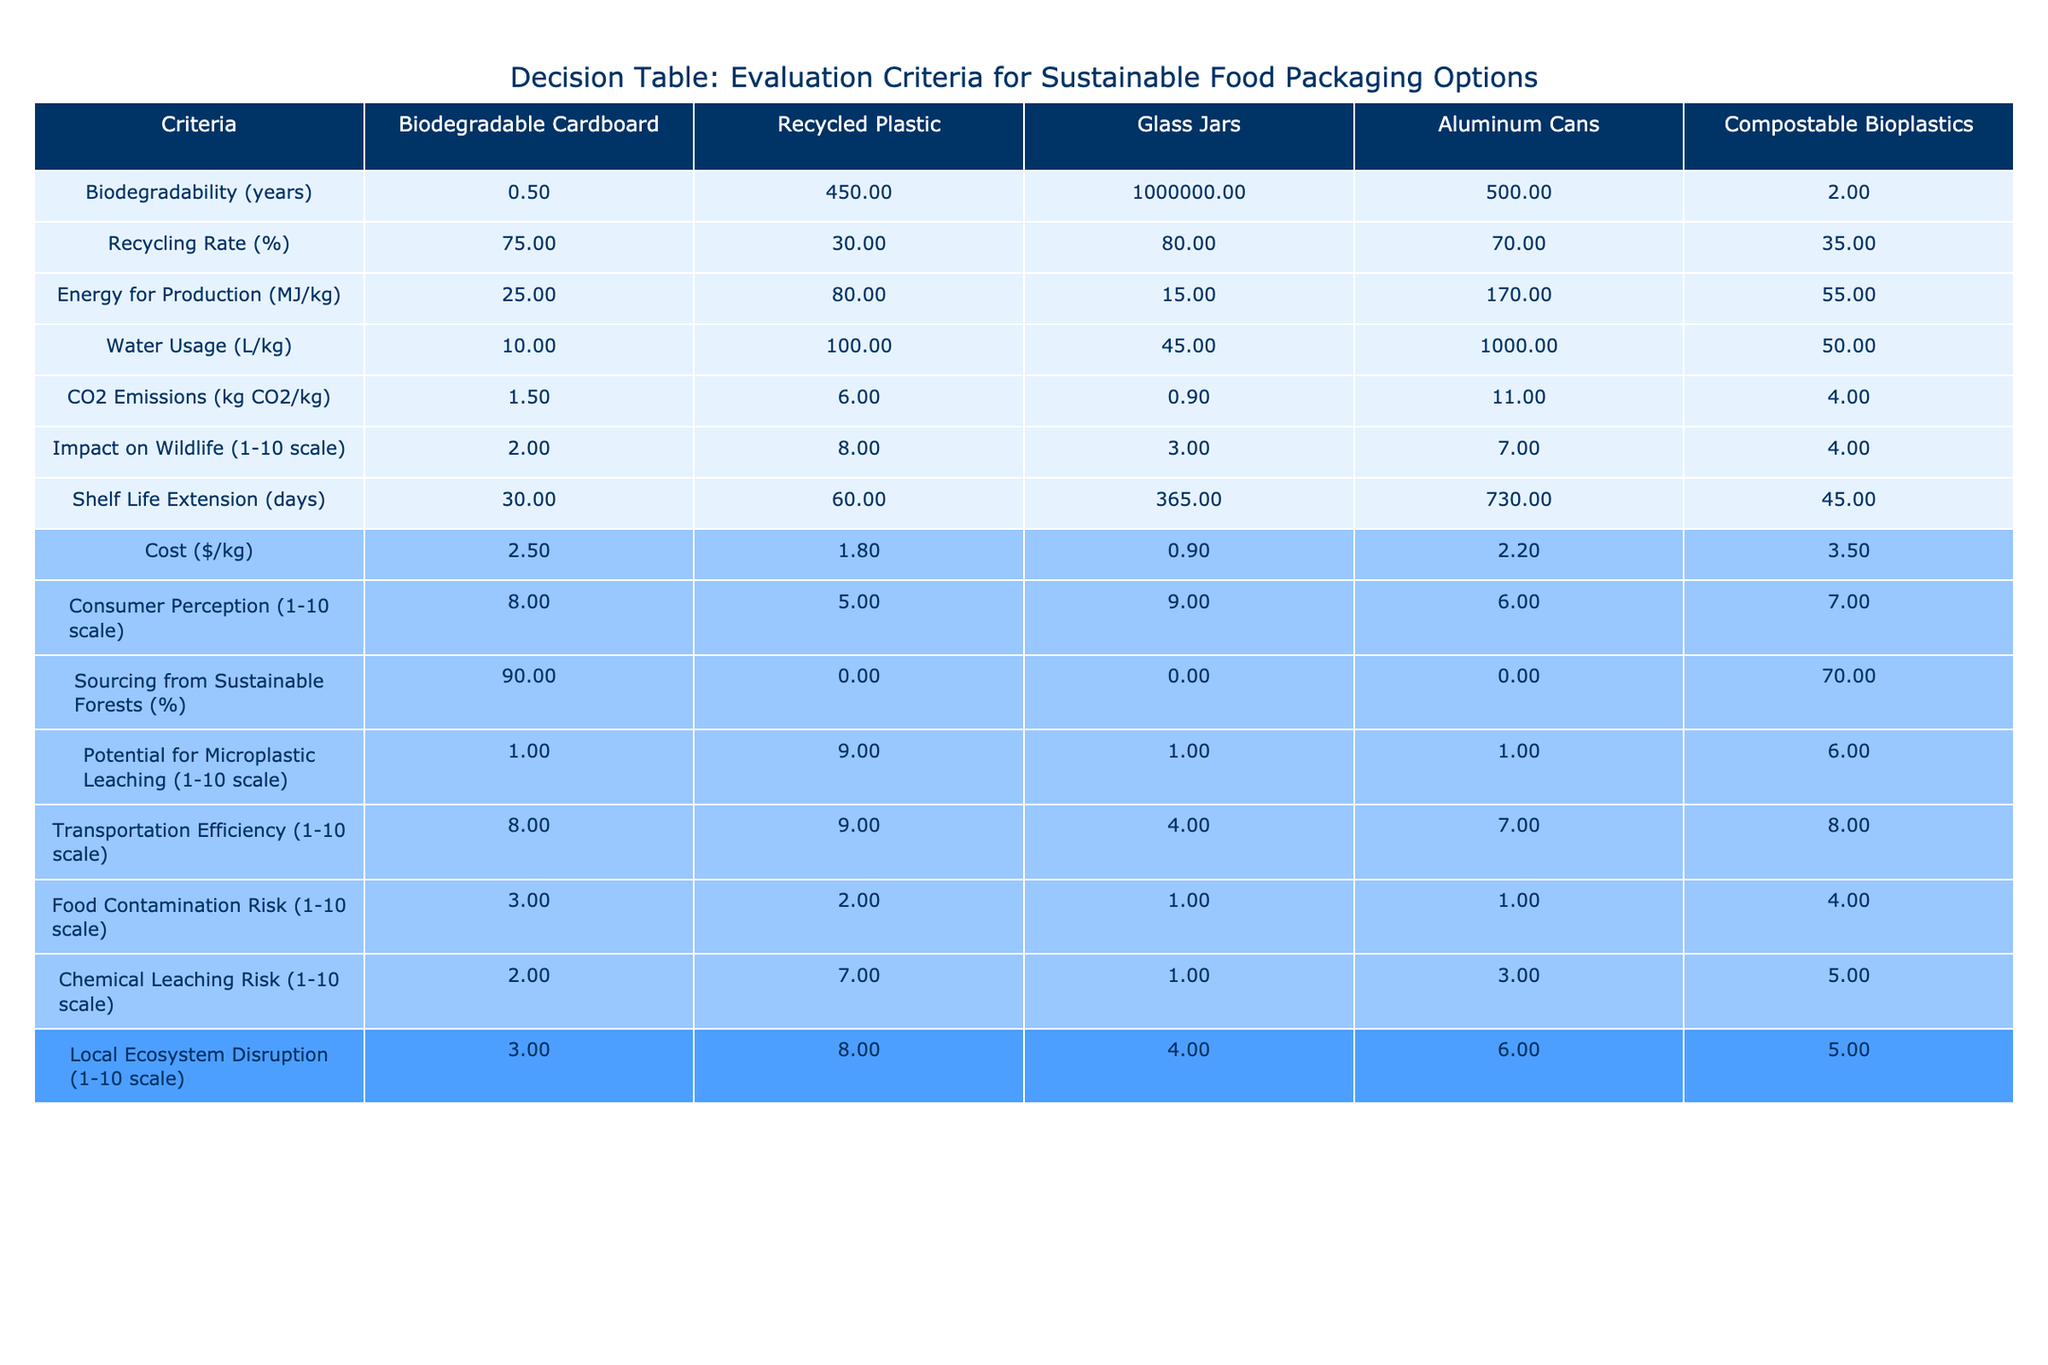What is the CO2 emission for Glass Jars? The value for CO2 emissions is directly listed under the column for Glass Jars, which shows 0.9 kg CO2/kg.
Answer: 0.9 kg CO2/kg Which packaging option has the highest recycling rate? By looking at the Recycling Rate column, Biodegradable Cardboard has the highest recycling rate of 75%.
Answer: Biodegradable Cardboard What is the average water usage for Biodegradable Cardboard and Compostable Bioplastics? Water usage for Biodegradable Cardboard is 10 L/kg and for Compostable Bioplastics is 50 L/kg. The average is (10 + 50) / 2 = 30 L/kg.
Answer: 30 L/kg Is the shelf life of Aluminum Cans longer than that of Glass Jars? The table shows that Aluminum Cans have a shelf life of 730 days and Glass Jars have 365 days, so 730 is greater than 365, making the statement true.
Answer: Yes Which packaging material has the lowest energy for production? Checking the Energy for Production column, Glass Jars have the lowest at 15 MJ/kg compared to other options.
Answer: Glass Jars What is the total potential for microplastic leaching for Recycled Plastic and Compostable Bioplastics? The values for Recycled Plastic and Compostable Bioplastics are 9 and 6, respectively. Adding them together gives 9 + 6 = 15.
Answer: 15 Which option ranks highest on the Impact on Wildlife scale? The Impact on Wildlife values indicate that Recycled Plastic has a score of 8, which is the highest among the listed options.
Answer: Recycled Plastic What is the cost difference between Recycled Plastic and Glass Jars? The cost of Recycled Plastic is $1.8/kg, and Glass Jars cost $0.9/kg. The difference is 1.8 - 0.9 = 0.9.
Answer: 0.9 Do all packaging options have a sourcing percentage from sustainable forests greater than 50%? Reviewing the Sourcing from Sustainable Forests column, only Biodegradable Cardboard (90%) meets this criterion, while others are all at 0% or below, thus the answer is no.
Answer: No 